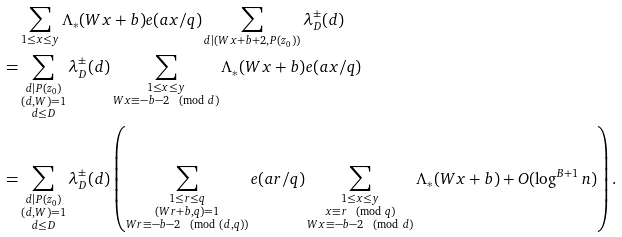<formula> <loc_0><loc_0><loc_500><loc_500>& \sum _ { \substack { 1 \leq x \leq y } } \Lambda _ { * } ( W x + b ) e ( a x / q ) \sum _ { d | ( W x + b + 2 , P ( z _ { 0 } ) ) } \lambda _ { D } ^ { \pm } ( d ) \\ = & \sum _ { \substack { d | P ( z _ { 0 } ) \\ ( d , W ) = 1 \\ d \leq D } } \lambda _ { D } ^ { \pm } ( d ) \sum _ { \substack { 1 \leq x \leq y \\ W x \equiv - b - 2 \pmod { d } } } \Lambda _ { * } ( W x + b ) e ( a x / q ) \\ = & \sum _ { \substack { d | P ( z _ { 0 } ) \\ ( d , W ) = 1 \\ d \leq D } } \lambda _ { D } ^ { \pm } ( d ) \left ( \sum _ { \substack { 1 \leq r \leq q \\ ( W r + b , q ) = 1 \\ W r \equiv - b - 2 \pmod { ( d , q ) } } } e ( a r / q ) \sum _ { \substack { 1 \leq x \leq y \\ x \equiv r \pmod { q } \\ W x \equiv - b - 2 \pmod { d } } } \Lambda _ { * } ( W x + b ) + O ( \log ^ { B + 1 } n ) \right ) .</formula> 